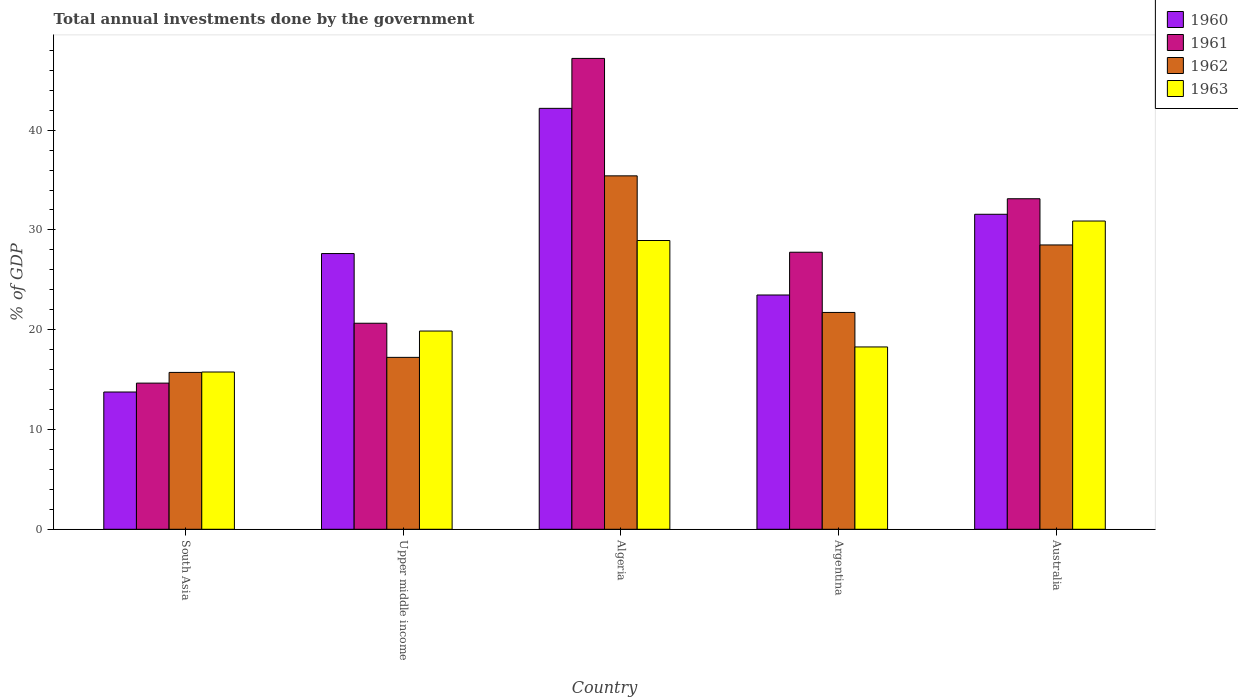How many groups of bars are there?
Ensure brevity in your answer.  5. How many bars are there on the 2nd tick from the right?
Offer a terse response. 4. What is the total annual investments done by the government in 1960 in Australia?
Ensure brevity in your answer.  31.57. Across all countries, what is the maximum total annual investments done by the government in 1962?
Keep it short and to the point. 35.42. Across all countries, what is the minimum total annual investments done by the government in 1961?
Keep it short and to the point. 14.65. In which country was the total annual investments done by the government in 1962 maximum?
Offer a terse response. Algeria. What is the total total annual investments done by the government in 1960 in the graph?
Provide a short and direct response. 138.62. What is the difference between the total annual investments done by the government in 1960 in Algeria and that in Upper middle income?
Keep it short and to the point. 14.55. What is the difference between the total annual investments done by the government in 1961 in Upper middle income and the total annual investments done by the government in 1962 in Australia?
Ensure brevity in your answer.  -7.85. What is the average total annual investments done by the government in 1961 per country?
Provide a short and direct response. 28.68. What is the difference between the total annual investments done by the government of/in 1961 and total annual investments done by the government of/in 1962 in Argentina?
Your answer should be compact. 6.04. In how many countries, is the total annual investments done by the government in 1963 greater than 8 %?
Give a very brief answer. 5. What is the ratio of the total annual investments done by the government in 1962 in Algeria to that in Argentina?
Ensure brevity in your answer.  1.63. Is the total annual investments done by the government in 1962 in Australia less than that in South Asia?
Give a very brief answer. No. What is the difference between the highest and the second highest total annual investments done by the government in 1960?
Your response must be concise. 14.55. What is the difference between the highest and the lowest total annual investments done by the government in 1960?
Offer a very short reply. 28.43. In how many countries, is the total annual investments done by the government in 1960 greater than the average total annual investments done by the government in 1960 taken over all countries?
Offer a very short reply. 2. What does the 2nd bar from the right in Argentina represents?
Make the answer very short. 1962. What is the difference between two consecutive major ticks on the Y-axis?
Offer a very short reply. 10. Does the graph contain any zero values?
Provide a short and direct response. No. What is the title of the graph?
Your answer should be very brief. Total annual investments done by the government. What is the label or title of the Y-axis?
Make the answer very short. % of GDP. What is the % of GDP in 1960 in South Asia?
Make the answer very short. 13.76. What is the % of GDP of 1961 in South Asia?
Your answer should be compact. 14.65. What is the % of GDP in 1962 in South Asia?
Offer a terse response. 15.72. What is the % of GDP of 1963 in South Asia?
Offer a very short reply. 15.76. What is the % of GDP in 1960 in Upper middle income?
Your answer should be compact. 27.63. What is the % of GDP of 1961 in Upper middle income?
Offer a terse response. 20.65. What is the % of GDP of 1962 in Upper middle income?
Give a very brief answer. 17.23. What is the % of GDP of 1963 in Upper middle income?
Keep it short and to the point. 19.87. What is the % of GDP in 1960 in Algeria?
Make the answer very short. 42.18. What is the % of GDP in 1961 in Algeria?
Your answer should be very brief. 47.19. What is the % of GDP of 1962 in Algeria?
Your answer should be very brief. 35.42. What is the % of GDP in 1963 in Algeria?
Provide a succinct answer. 28.94. What is the % of GDP in 1960 in Argentina?
Provide a succinct answer. 23.48. What is the % of GDP of 1961 in Argentina?
Keep it short and to the point. 27.77. What is the % of GDP of 1962 in Argentina?
Your response must be concise. 21.73. What is the % of GDP in 1963 in Argentina?
Your response must be concise. 18.27. What is the % of GDP in 1960 in Australia?
Give a very brief answer. 31.57. What is the % of GDP of 1961 in Australia?
Your answer should be very brief. 33.13. What is the % of GDP of 1962 in Australia?
Your answer should be compact. 28.49. What is the % of GDP of 1963 in Australia?
Provide a succinct answer. 30.89. Across all countries, what is the maximum % of GDP of 1960?
Give a very brief answer. 42.18. Across all countries, what is the maximum % of GDP in 1961?
Provide a short and direct response. 47.19. Across all countries, what is the maximum % of GDP in 1962?
Your answer should be compact. 35.42. Across all countries, what is the maximum % of GDP of 1963?
Ensure brevity in your answer.  30.89. Across all countries, what is the minimum % of GDP of 1960?
Offer a very short reply. 13.76. Across all countries, what is the minimum % of GDP of 1961?
Your answer should be very brief. 14.65. Across all countries, what is the minimum % of GDP in 1962?
Give a very brief answer. 15.72. Across all countries, what is the minimum % of GDP of 1963?
Provide a short and direct response. 15.76. What is the total % of GDP in 1960 in the graph?
Make the answer very short. 138.62. What is the total % of GDP in 1961 in the graph?
Provide a short and direct response. 143.38. What is the total % of GDP in 1962 in the graph?
Offer a terse response. 118.6. What is the total % of GDP of 1963 in the graph?
Make the answer very short. 113.74. What is the difference between the % of GDP in 1960 in South Asia and that in Upper middle income?
Provide a short and direct response. -13.88. What is the difference between the % of GDP of 1961 in South Asia and that in Upper middle income?
Your answer should be very brief. -6. What is the difference between the % of GDP of 1962 in South Asia and that in Upper middle income?
Provide a succinct answer. -1.51. What is the difference between the % of GDP in 1963 in South Asia and that in Upper middle income?
Make the answer very short. -4.1. What is the difference between the % of GDP of 1960 in South Asia and that in Algeria?
Make the answer very short. -28.43. What is the difference between the % of GDP of 1961 in South Asia and that in Algeria?
Offer a terse response. -32.54. What is the difference between the % of GDP of 1962 in South Asia and that in Algeria?
Offer a terse response. -19.7. What is the difference between the % of GDP in 1963 in South Asia and that in Algeria?
Your response must be concise. -13.18. What is the difference between the % of GDP in 1960 in South Asia and that in Argentina?
Ensure brevity in your answer.  -9.72. What is the difference between the % of GDP of 1961 in South Asia and that in Argentina?
Keep it short and to the point. -13.12. What is the difference between the % of GDP of 1962 in South Asia and that in Argentina?
Make the answer very short. -6.01. What is the difference between the % of GDP in 1963 in South Asia and that in Argentina?
Make the answer very short. -2.51. What is the difference between the % of GDP in 1960 in South Asia and that in Australia?
Provide a succinct answer. -17.81. What is the difference between the % of GDP of 1961 in South Asia and that in Australia?
Offer a terse response. -18.48. What is the difference between the % of GDP in 1962 in South Asia and that in Australia?
Offer a very short reply. -12.77. What is the difference between the % of GDP of 1963 in South Asia and that in Australia?
Your answer should be very brief. -15.13. What is the difference between the % of GDP of 1960 in Upper middle income and that in Algeria?
Your answer should be compact. -14.55. What is the difference between the % of GDP in 1961 in Upper middle income and that in Algeria?
Make the answer very short. -26.54. What is the difference between the % of GDP of 1962 in Upper middle income and that in Algeria?
Ensure brevity in your answer.  -18.19. What is the difference between the % of GDP in 1963 in Upper middle income and that in Algeria?
Offer a very short reply. -9.07. What is the difference between the % of GDP in 1960 in Upper middle income and that in Argentina?
Provide a succinct answer. 4.15. What is the difference between the % of GDP of 1961 in Upper middle income and that in Argentina?
Offer a very short reply. -7.12. What is the difference between the % of GDP in 1962 in Upper middle income and that in Argentina?
Give a very brief answer. -4.5. What is the difference between the % of GDP in 1963 in Upper middle income and that in Argentina?
Ensure brevity in your answer.  1.59. What is the difference between the % of GDP of 1960 in Upper middle income and that in Australia?
Your answer should be very brief. -3.94. What is the difference between the % of GDP of 1961 in Upper middle income and that in Australia?
Ensure brevity in your answer.  -12.48. What is the difference between the % of GDP in 1962 in Upper middle income and that in Australia?
Offer a very short reply. -11.27. What is the difference between the % of GDP of 1963 in Upper middle income and that in Australia?
Ensure brevity in your answer.  -11.03. What is the difference between the % of GDP of 1960 in Algeria and that in Argentina?
Provide a short and direct response. 18.71. What is the difference between the % of GDP of 1961 in Algeria and that in Argentina?
Give a very brief answer. 19.42. What is the difference between the % of GDP of 1962 in Algeria and that in Argentina?
Ensure brevity in your answer.  13.69. What is the difference between the % of GDP in 1963 in Algeria and that in Argentina?
Give a very brief answer. 10.67. What is the difference between the % of GDP of 1960 in Algeria and that in Australia?
Your answer should be compact. 10.61. What is the difference between the % of GDP of 1961 in Algeria and that in Australia?
Your answer should be very brief. 14.06. What is the difference between the % of GDP in 1962 in Algeria and that in Australia?
Give a very brief answer. 6.93. What is the difference between the % of GDP in 1963 in Algeria and that in Australia?
Offer a very short reply. -1.95. What is the difference between the % of GDP in 1960 in Argentina and that in Australia?
Your answer should be compact. -8.09. What is the difference between the % of GDP of 1961 in Argentina and that in Australia?
Your response must be concise. -5.36. What is the difference between the % of GDP in 1962 in Argentina and that in Australia?
Your answer should be very brief. -6.76. What is the difference between the % of GDP of 1963 in Argentina and that in Australia?
Your answer should be compact. -12.62. What is the difference between the % of GDP of 1960 in South Asia and the % of GDP of 1961 in Upper middle income?
Provide a succinct answer. -6.89. What is the difference between the % of GDP of 1960 in South Asia and the % of GDP of 1962 in Upper middle income?
Provide a succinct answer. -3.47. What is the difference between the % of GDP of 1960 in South Asia and the % of GDP of 1963 in Upper middle income?
Provide a succinct answer. -6.11. What is the difference between the % of GDP of 1961 in South Asia and the % of GDP of 1962 in Upper middle income?
Offer a very short reply. -2.58. What is the difference between the % of GDP in 1961 in South Asia and the % of GDP in 1963 in Upper middle income?
Keep it short and to the point. -5.22. What is the difference between the % of GDP in 1962 in South Asia and the % of GDP in 1963 in Upper middle income?
Ensure brevity in your answer.  -4.15. What is the difference between the % of GDP of 1960 in South Asia and the % of GDP of 1961 in Algeria?
Make the answer very short. -33.43. What is the difference between the % of GDP of 1960 in South Asia and the % of GDP of 1962 in Algeria?
Give a very brief answer. -21.66. What is the difference between the % of GDP of 1960 in South Asia and the % of GDP of 1963 in Algeria?
Make the answer very short. -15.18. What is the difference between the % of GDP of 1961 in South Asia and the % of GDP of 1962 in Algeria?
Ensure brevity in your answer.  -20.77. What is the difference between the % of GDP of 1961 in South Asia and the % of GDP of 1963 in Algeria?
Ensure brevity in your answer.  -14.29. What is the difference between the % of GDP of 1962 in South Asia and the % of GDP of 1963 in Algeria?
Provide a short and direct response. -13.22. What is the difference between the % of GDP of 1960 in South Asia and the % of GDP of 1961 in Argentina?
Your response must be concise. -14.01. What is the difference between the % of GDP in 1960 in South Asia and the % of GDP in 1962 in Argentina?
Your response must be concise. -7.97. What is the difference between the % of GDP of 1960 in South Asia and the % of GDP of 1963 in Argentina?
Offer a terse response. -4.52. What is the difference between the % of GDP in 1961 in South Asia and the % of GDP in 1962 in Argentina?
Your response must be concise. -7.08. What is the difference between the % of GDP of 1961 in South Asia and the % of GDP of 1963 in Argentina?
Provide a succinct answer. -3.62. What is the difference between the % of GDP in 1962 in South Asia and the % of GDP in 1963 in Argentina?
Provide a succinct answer. -2.55. What is the difference between the % of GDP in 1960 in South Asia and the % of GDP in 1961 in Australia?
Your answer should be very brief. -19.37. What is the difference between the % of GDP of 1960 in South Asia and the % of GDP of 1962 in Australia?
Provide a succinct answer. -14.74. What is the difference between the % of GDP of 1960 in South Asia and the % of GDP of 1963 in Australia?
Provide a short and direct response. -17.14. What is the difference between the % of GDP in 1961 in South Asia and the % of GDP in 1962 in Australia?
Keep it short and to the point. -13.85. What is the difference between the % of GDP in 1961 in South Asia and the % of GDP in 1963 in Australia?
Provide a succinct answer. -16.25. What is the difference between the % of GDP of 1962 in South Asia and the % of GDP of 1963 in Australia?
Your answer should be very brief. -15.17. What is the difference between the % of GDP in 1960 in Upper middle income and the % of GDP in 1961 in Algeria?
Your answer should be very brief. -19.56. What is the difference between the % of GDP of 1960 in Upper middle income and the % of GDP of 1962 in Algeria?
Keep it short and to the point. -7.79. What is the difference between the % of GDP of 1960 in Upper middle income and the % of GDP of 1963 in Algeria?
Keep it short and to the point. -1.31. What is the difference between the % of GDP in 1961 in Upper middle income and the % of GDP in 1962 in Algeria?
Give a very brief answer. -14.77. What is the difference between the % of GDP of 1961 in Upper middle income and the % of GDP of 1963 in Algeria?
Keep it short and to the point. -8.29. What is the difference between the % of GDP in 1962 in Upper middle income and the % of GDP in 1963 in Algeria?
Offer a terse response. -11.71. What is the difference between the % of GDP of 1960 in Upper middle income and the % of GDP of 1961 in Argentina?
Ensure brevity in your answer.  -0.13. What is the difference between the % of GDP of 1960 in Upper middle income and the % of GDP of 1962 in Argentina?
Keep it short and to the point. 5.9. What is the difference between the % of GDP of 1960 in Upper middle income and the % of GDP of 1963 in Argentina?
Give a very brief answer. 9.36. What is the difference between the % of GDP of 1961 in Upper middle income and the % of GDP of 1962 in Argentina?
Offer a terse response. -1.08. What is the difference between the % of GDP in 1961 in Upper middle income and the % of GDP in 1963 in Argentina?
Offer a very short reply. 2.38. What is the difference between the % of GDP in 1962 in Upper middle income and the % of GDP in 1963 in Argentina?
Make the answer very short. -1.04. What is the difference between the % of GDP in 1960 in Upper middle income and the % of GDP in 1961 in Australia?
Your answer should be very brief. -5.49. What is the difference between the % of GDP in 1960 in Upper middle income and the % of GDP in 1962 in Australia?
Make the answer very short. -0.86. What is the difference between the % of GDP in 1960 in Upper middle income and the % of GDP in 1963 in Australia?
Give a very brief answer. -3.26. What is the difference between the % of GDP in 1961 in Upper middle income and the % of GDP in 1962 in Australia?
Offer a terse response. -7.85. What is the difference between the % of GDP of 1961 in Upper middle income and the % of GDP of 1963 in Australia?
Offer a very short reply. -10.24. What is the difference between the % of GDP in 1962 in Upper middle income and the % of GDP in 1963 in Australia?
Give a very brief answer. -13.67. What is the difference between the % of GDP of 1960 in Algeria and the % of GDP of 1961 in Argentina?
Make the answer very short. 14.42. What is the difference between the % of GDP in 1960 in Algeria and the % of GDP in 1962 in Argentina?
Your response must be concise. 20.45. What is the difference between the % of GDP in 1960 in Algeria and the % of GDP in 1963 in Argentina?
Make the answer very short. 23.91. What is the difference between the % of GDP of 1961 in Algeria and the % of GDP of 1962 in Argentina?
Your response must be concise. 25.46. What is the difference between the % of GDP of 1961 in Algeria and the % of GDP of 1963 in Argentina?
Your response must be concise. 28.92. What is the difference between the % of GDP of 1962 in Algeria and the % of GDP of 1963 in Argentina?
Your response must be concise. 17.15. What is the difference between the % of GDP in 1960 in Algeria and the % of GDP in 1961 in Australia?
Provide a short and direct response. 9.06. What is the difference between the % of GDP in 1960 in Algeria and the % of GDP in 1962 in Australia?
Make the answer very short. 13.69. What is the difference between the % of GDP of 1960 in Algeria and the % of GDP of 1963 in Australia?
Ensure brevity in your answer.  11.29. What is the difference between the % of GDP in 1961 in Algeria and the % of GDP in 1962 in Australia?
Your answer should be very brief. 18.69. What is the difference between the % of GDP in 1961 in Algeria and the % of GDP in 1963 in Australia?
Provide a succinct answer. 16.3. What is the difference between the % of GDP of 1962 in Algeria and the % of GDP of 1963 in Australia?
Ensure brevity in your answer.  4.53. What is the difference between the % of GDP in 1960 in Argentina and the % of GDP in 1961 in Australia?
Provide a short and direct response. -9.65. What is the difference between the % of GDP of 1960 in Argentina and the % of GDP of 1962 in Australia?
Your answer should be very brief. -5.02. What is the difference between the % of GDP in 1960 in Argentina and the % of GDP in 1963 in Australia?
Offer a terse response. -7.41. What is the difference between the % of GDP of 1961 in Argentina and the % of GDP of 1962 in Australia?
Give a very brief answer. -0.73. What is the difference between the % of GDP of 1961 in Argentina and the % of GDP of 1963 in Australia?
Make the answer very short. -3.13. What is the difference between the % of GDP of 1962 in Argentina and the % of GDP of 1963 in Australia?
Your answer should be very brief. -9.16. What is the average % of GDP of 1960 per country?
Offer a terse response. 27.72. What is the average % of GDP of 1961 per country?
Provide a succinct answer. 28.68. What is the average % of GDP of 1962 per country?
Your response must be concise. 23.72. What is the average % of GDP of 1963 per country?
Offer a very short reply. 22.75. What is the difference between the % of GDP in 1960 and % of GDP in 1961 in South Asia?
Your response must be concise. -0.89. What is the difference between the % of GDP of 1960 and % of GDP of 1962 in South Asia?
Make the answer very short. -1.96. What is the difference between the % of GDP in 1960 and % of GDP in 1963 in South Asia?
Give a very brief answer. -2.01. What is the difference between the % of GDP of 1961 and % of GDP of 1962 in South Asia?
Make the answer very short. -1.07. What is the difference between the % of GDP in 1961 and % of GDP in 1963 in South Asia?
Give a very brief answer. -1.11. What is the difference between the % of GDP in 1962 and % of GDP in 1963 in South Asia?
Ensure brevity in your answer.  -0.04. What is the difference between the % of GDP of 1960 and % of GDP of 1961 in Upper middle income?
Provide a succinct answer. 6.98. What is the difference between the % of GDP of 1960 and % of GDP of 1962 in Upper middle income?
Offer a terse response. 10.4. What is the difference between the % of GDP in 1960 and % of GDP in 1963 in Upper middle income?
Offer a very short reply. 7.77. What is the difference between the % of GDP in 1961 and % of GDP in 1962 in Upper middle income?
Your response must be concise. 3.42. What is the difference between the % of GDP of 1961 and % of GDP of 1963 in Upper middle income?
Provide a short and direct response. 0.78. What is the difference between the % of GDP of 1962 and % of GDP of 1963 in Upper middle income?
Give a very brief answer. -2.64. What is the difference between the % of GDP of 1960 and % of GDP of 1961 in Algeria?
Offer a very short reply. -5. What is the difference between the % of GDP in 1960 and % of GDP in 1962 in Algeria?
Provide a short and direct response. 6.76. What is the difference between the % of GDP of 1960 and % of GDP of 1963 in Algeria?
Your response must be concise. 13.24. What is the difference between the % of GDP in 1961 and % of GDP in 1962 in Algeria?
Offer a terse response. 11.77. What is the difference between the % of GDP of 1961 and % of GDP of 1963 in Algeria?
Your answer should be very brief. 18.25. What is the difference between the % of GDP of 1962 and % of GDP of 1963 in Algeria?
Provide a short and direct response. 6.48. What is the difference between the % of GDP of 1960 and % of GDP of 1961 in Argentina?
Give a very brief answer. -4.29. What is the difference between the % of GDP in 1960 and % of GDP in 1962 in Argentina?
Keep it short and to the point. 1.75. What is the difference between the % of GDP in 1960 and % of GDP in 1963 in Argentina?
Make the answer very short. 5.21. What is the difference between the % of GDP of 1961 and % of GDP of 1962 in Argentina?
Make the answer very short. 6.04. What is the difference between the % of GDP of 1961 and % of GDP of 1963 in Argentina?
Your response must be concise. 9.49. What is the difference between the % of GDP of 1962 and % of GDP of 1963 in Argentina?
Your answer should be compact. 3.46. What is the difference between the % of GDP in 1960 and % of GDP in 1961 in Australia?
Make the answer very short. -1.56. What is the difference between the % of GDP of 1960 and % of GDP of 1962 in Australia?
Your answer should be very brief. 3.08. What is the difference between the % of GDP of 1960 and % of GDP of 1963 in Australia?
Provide a succinct answer. 0.68. What is the difference between the % of GDP in 1961 and % of GDP in 1962 in Australia?
Offer a very short reply. 4.63. What is the difference between the % of GDP in 1961 and % of GDP in 1963 in Australia?
Your answer should be very brief. 2.23. What is the difference between the % of GDP of 1962 and % of GDP of 1963 in Australia?
Your answer should be compact. -2.4. What is the ratio of the % of GDP of 1960 in South Asia to that in Upper middle income?
Provide a succinct answer. 0.5. What is the ratio of the % of GDP in 1961 in South Asia to that in Upper middle income?
Your answer should be very brief. 0.71. What is the ratio of the % of GDP in 1962 in South Asia to that in Upper middle income?
Offer a terse response. 0.91. What is the ratio of the % of GDP of 1963 in South Asia to that in Upper middle income?
Make the answer very short. 0.79. What is the ratio of the % of GDP of 1960 in South Asia to that in Algeria?
Give a very brief answer. 0.33. What is the ratio of the % of GDP of 1961 in South Asia to that in Algeria?
Ensure brevity in your answer.  0.31. What is the ratio of the % of GDP of 1962 in South Asia to that in Algeria?
Your response must be concise. 0.44. What is the ratio of the % of GDP in 1963 in South Asia to that in Algeria?
Offer a terse response. 0.54. What is the ratio of the % of GDP of 1960 in South Asia to that in Argentina?
Provide a short and direct response. 0.59. What is the ratio of the % of GDP in 1961 in South Asia to that in Argentina?
Your answer should be very brief. 0.53. What is the ratio of the % of GDP in 1962 in South Asia to that in Argentina?
Your response must be concise. 0.72. What is the ratio of the % of GDP of 1963 in South Asia to that in Argentina?
Provide a short and direct response. 0.86. What is the ratio of the % of GDP of 1960 in South Asia to that in Australia?
Offer a very short reply. 0.44. What is the ratio of the % of GDP in 1961 in South Asia to that in Australia?
Your response must be concise. 0.44. What is the ratio of the % of GDP of 1962 in South Asia to that in Australia?
Provide a succinct answer. 0.55. What is the ratio of the % of GDP in 1963 in South Asia to that in Australia?
Keep it short and to the point. 0.51. What is the ratio of the % of GDP of 1960 in Upper middle income to that in Algeria?
Provide a succinct answer. 0.66. What is the ratio of the % of GDP of 1961 in Upper middle income to that in Algeria?
Provide a succinct answer. 0.44. What is the ratio of the % of GDP of 1962 in Upper middle income to that in Algeria?
Provide a short and direct response. 0.49. What is the ratio of the % of GDP of 1963 in Upper middle income to that in Algeria?
Ensure brevity in your answer.  0.69. What is the ratio of the % of GDP in 1960 in Upper middle income to that in Argentina?
Ensure brevity in your answer.  1.18. What is the ratio of the % of GDP of 1961 in Upper middle income to that in Argentina?
Make the answer very short. 0.74. What is the ratio of the % of GDP in 1962 in Upper middle income to that in Argentina?
Keep it short and to the point. 0.79. What is the ratio of the % of GDP in 1963 in Upper middle income to that in Argentina?
Offer a terse response. 1.09. What is the ratio of the % of GDP in 1960 in Upper middle income to that in Australia?
Make the answer very short. 0.88. What is the ratio of the % of GDP of 1961 in Upper middle income to that in Australia?
Give a very brief answer. 0.62. What is the ratio of the % of GDP in 1962 in Upper middle income to that in Australia?
Keep it short and to the point. 0.6. What is the ratio of the % of GDP of 1963 in Upper middle income to that in Australia?
Ensure brevity in your answer.  0.64. What is the ratio of the % of GDP in 1960 in Algeria to that in Argentina?
Provide a succinct answer. 1.8. What is the ratio of the % of GDP of 1961 in Algeria to that in Argentina?
Offer a very short reply. 1.7. What is the ratio of the % of GDP in 1962 in Algeria to that in Argentina?
Your response must be concise. 1.63. What is the ratio of the % of GDP in 1963 in Algeria to that in Argentina?
Offer a terse response. 1.58. What is the ratio of the % of GDP of 1960 in Algeria to that in Australia?
Ensure brevity in your answer.  1.34. What is the ratio of the % of GDP in 1961 in Algeria to that in Australia?
Your response must be concise. 1.42. What is the ratio of the % of GDP in 1962 in Algeria to that in Australia?
Your response must be concise. 1.24. What is the ratio of the % of GDP in 1963 in Algeria to that in Australia?
Make the answer very short. 0.94. What is the ratio of the % of GDP in 1960 in Argentina to that in Australia?
Your answer should be very brief. 0.74. What is the ratio of the % of GDP in 1961 in Argentina to that in Australia?
Your answer should be very brief. 0.84. What is the ratio of the % of GDP of 1962 in Argentina to that in Australia?
Provide a succinct answer. 0.76. What is the ratio of the % of GDP in 1963 in Argentina to that in Australia?
Your answer should be very brief. 0.59. What is the difference between the highest and the second highest % of GDP in 1960?
Provide a succinct answer. 10.61. What is the difference between the highest and the second highest % of GDP in 1961?
Your answer should be compact. 14.06. What is the difference between the highest and the second highest % of GDP of 1962?
Provide a short and direct response. 6.93. What is the difference between the highest and the second highest % of GDP of 1963?
Offer a very short reply. 1.95. What is the difference between the highest and the lowest % of GDP in 1960?
Your response must be concise. 28.43. What is the difference between the highest and the lowest % of GDP of 1961?
Offer a very short reply. 32.54. What is the difference between the highest and the lowest % of GDP in 1962?
Ensure brevity in your answer.  19.7. What is the difference between the highest and the lowest % of GDP of 1963?
Provide a succinct answer. 15.13. 